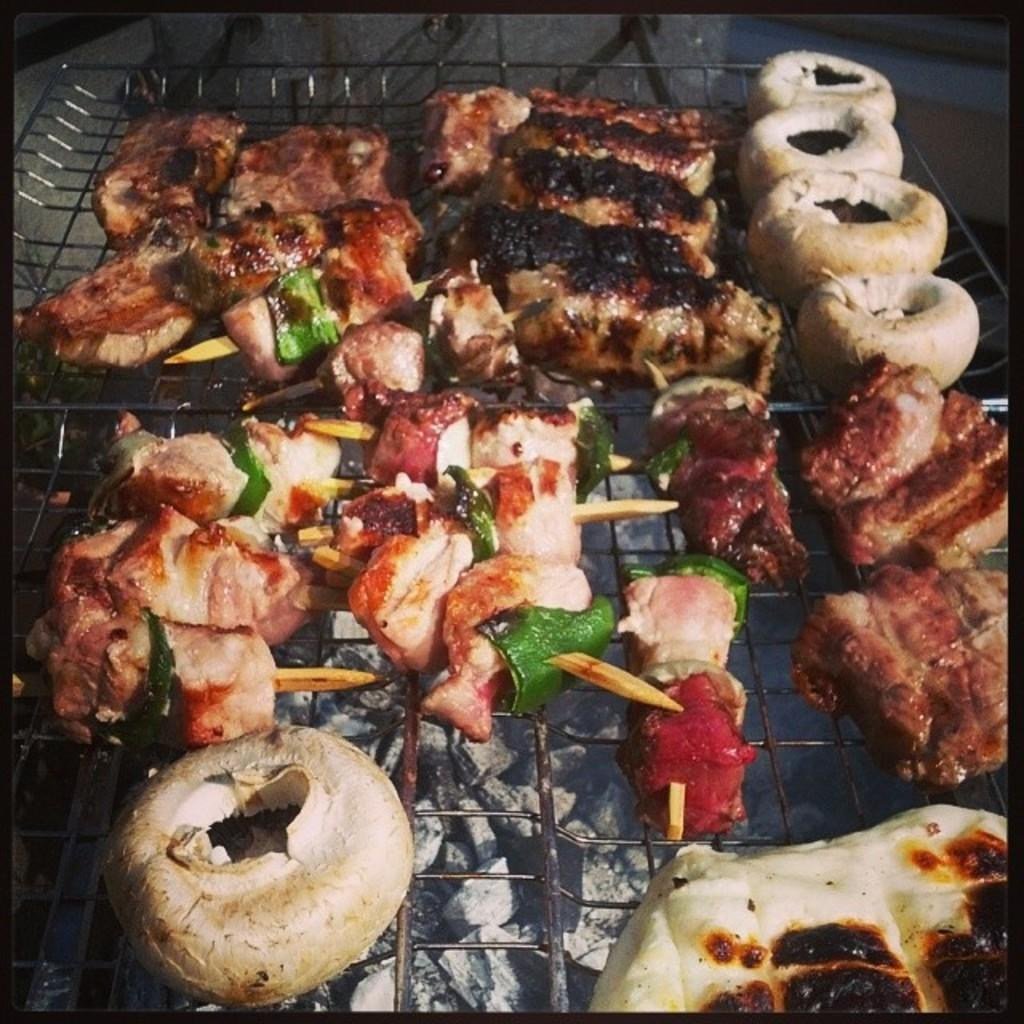What is being cooked on the grill in the image? There is food on the grill in the image. What type of fuel is being used for the grill? There is charcoal visible in the image. What type of cord is being used to tell a story in the image? There is no cord or storytelling depicted in the image; it only shows food on a grill and charcoal. 